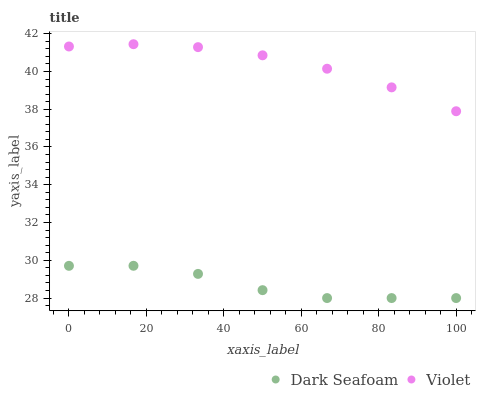Does Dark Seafoam have the minimum area under the curve?
Answer yes or no. Yes. Does Violet have the maximum area under the curve?
Answer yes or no. Yes. Does Violet have the minimum area under the curve?
Answer yes or no. No. Is Violet the smoothest?
Answer yes or no. Yes. Is Dark Seafoam the roughest?
Answer yes or no. Yes. Is Violet the roughest?
Answer yes or no. No. Does Dark Seafoam have the lowest value?
Answer yes or no. Yes. Does Violet have the lowest value?
Answer yes or no. No. Does Violet have the highest value?
Answer yes or no. Yes. Is Dark Seafoam less than Violet?
Answer yes or no. Yes. Is Violet greater than Dark Seafoam?
Answer yes or no. Yes. Does Dark Seafoam intersect Violet?
Answer yes or no. No. 